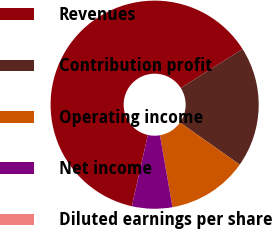Convert chart to OTSL. <chart><loc_0><loc_0><loc_500><loc_500><pie_chart><fcel>Revenues<fcel>Contribution profit<fcel>Operating income<fcel>Net income<fcel>Diluted earnings per share<nl><fcel>62.5%<fcel>18.75%<fcel>12.5%<fcel>6.25%<fcel>0.0%<nl></chart> 